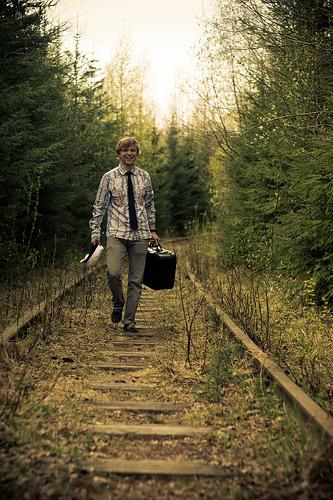Question: who is walking?
Choices:
A. Girl.
B. A man.
C. Baby.
D. Toddler.
Answer with the letter. Answer: B Question: how many people are shown?
Choices:
A. 2.
B. 3.
C. 1.
D. 4.
Answer with the letter. Answer: C Question: why is the man smiling?
Choices:
A. It's his birthday.
B. For the picture.
C. His kids are home.
D. He is watching a movie.
Answer with the letter. Answer: B 